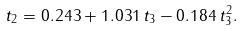<formula> <loc_0><loc_0><loc_500><loc_500>t _ { 2 } = 0 . 2 4 3 + 1 . 0 3 1 \, t _ { 3 } - 0 . 1 8 4 \, t _ { 3 } ^ { 2 } .</formula> 